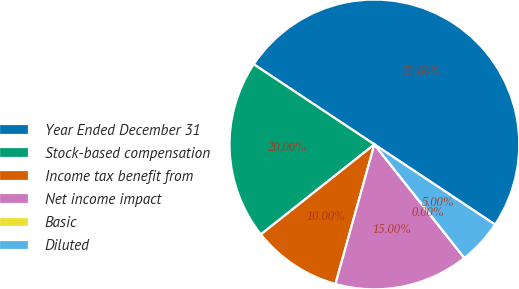<chart> <loc_0><loc_0><loc_500><loc_500><pie_chart><fcel>Year Ended December 31<fcel>Stock-based compensation<fcel>Income tax benefit from<fcel>Net income impact<fcel>Basic<fcel>Diluted<nl><fcel>50.0%<fcel>20.0%<fcel>10.0%<fcel>15.0%<fcel>0.0%<fcel>5.0%<nl></chart> 